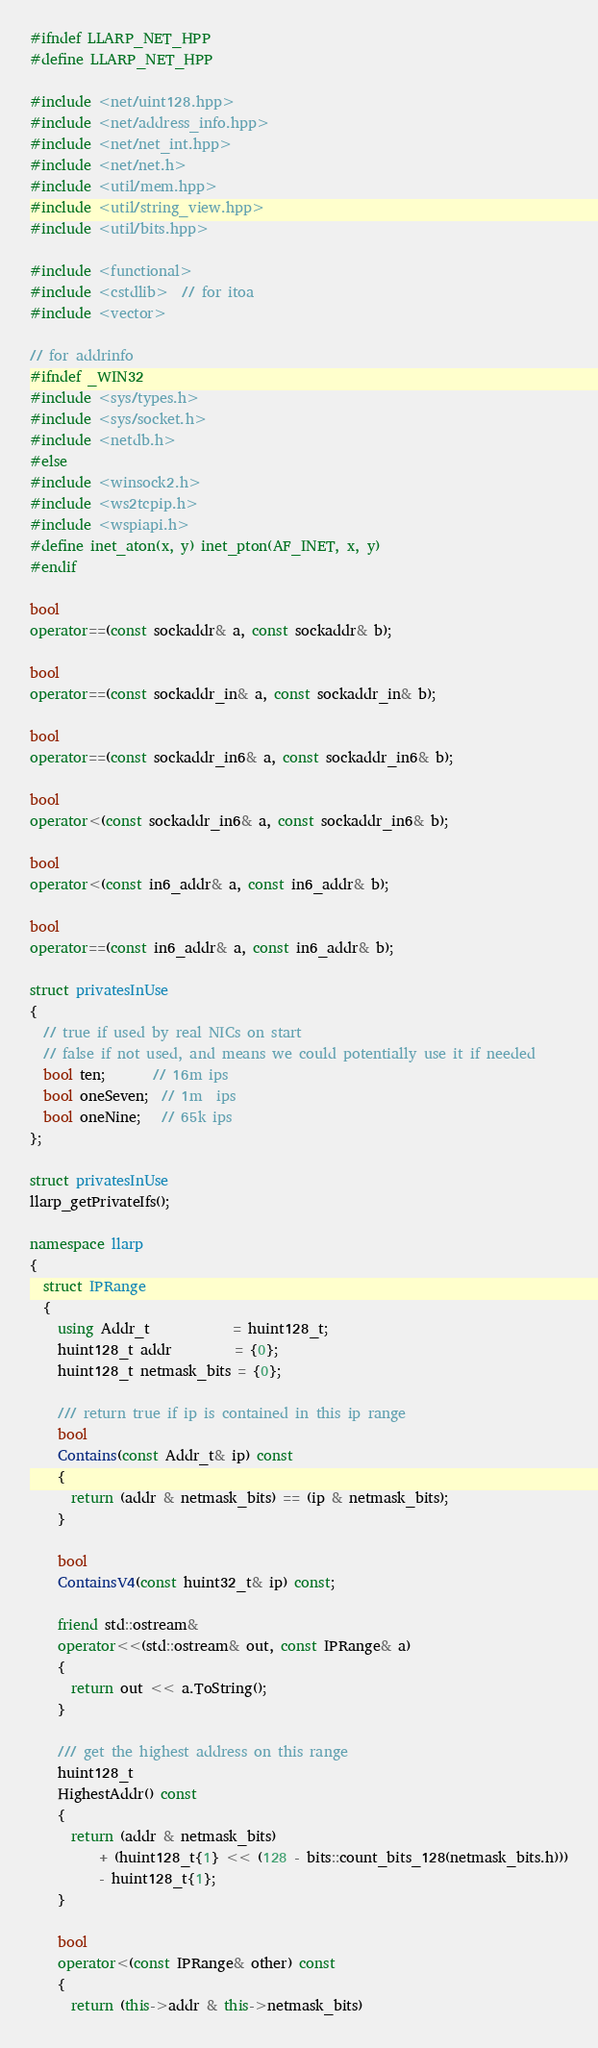Convert code to text. <code><loc_0><loc_0><loc_500><loc_500><_C++_>#ifndef LLARP_NET_HPP
#define LLARP_NET_HPP

#include <net/uint128.hpp>
#include <net/address_info.hpp>
#include <net/net_int.hpp>
#include <net/net.h>
#include <util/mem.hpp>
#include <util/string_view.hpp>
#include <util/bits.hpp>

#include <functional>
#include <cstdlib>  // for itoa
#include <vector>

// for addrinfo
#ifndef _WIN32
#include <sys/types.h>
#include <sys/socket.h>
#include <netdb.h>
#else
#include <winsock2.h>
#include <ws2tcpip.h>
#include <wspiapi.h>
#define inet_aton(x, y) inet_pton(AF_INET, x, y)
#endif

bool
operator==(const sockaddr& a, const sockaddr& b);

bool
operator==(const sockaddr_in& a, const sockaddr_in& b);

bool
operator==(const sockaddr_in6& a, const sockaddr_in6& b);

bool
operator<(const sockaddr_in6& a, const sockaddr_in6& b);

bool
operator<(const in6_addr& a, const in6_addr& b);

bool
operator==(const in6_addr& a, const in6_addr& b);

struct privatesInUse
{
  // true if used by real NICs on start
  // false if not used, and means we could potentially use it if needed
  bool ten;       // 16m ips
  bool oneSeven;  // 1m  ips
  bool oneNine;   // 65k ips
};

struct privatesInUse
llarp_getPrivateIfs();

namespace llarp
{
  struct IPRange
  {
    using Addr_t            = huint128_t;
    huint128_t addr         = {0};
    huint128_t netmask_bits = {0};

    /// return true if ip is contained in this ip range
    bool
    Contains(const Addr_t& ip) const
    {
      return (addr & netmask_bits) == (ip & netmask_bits);
    }

    bool
    ContainsV4(const huint32_t& ip) const;

    friend std::ostream&
    operator<<(std::ostream& out, const IPRange& a)
    {
      return out << a.ToString();
    }

    /// get the highest address on this range
    huint128_t
    HighestAddr() const
    {
      return (addr & netmask_bits)
          + (huint128_t{1} << (128 - bits::count_bits_128(netmask_bits.h)))
          - huint128_t{1};
    }

    bool
    operator<(const IPRange& other) const
    {
      return (this->addr & this->netmask_bits)</code> 